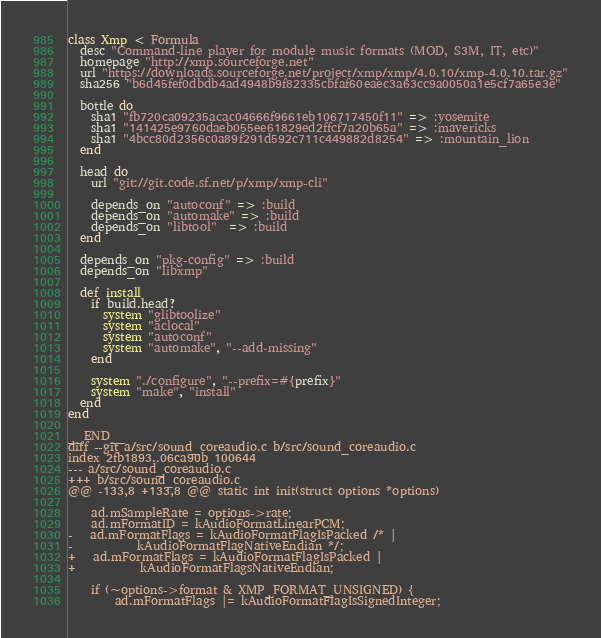Convert code to text. <code><loc_0><loc_0><loc_500><loc_500><_Ruby_>class Xmp < Formula
  desc "Command-line player for module music formats (MOD, S3M, IT, etc)"
  homepage "http://xmp.sourceforge.net"
  url "https://downloads.sourceforge.net/project/xmp/xmp/4.0.10/xmp-4.0.10.tar.gz"
  sha256 "b6d45fef0dbdb4ad4948b9f82335cbfaf60eaec3a63cc9a0050a1e5cf7a65e3e"

  bottle do
    sha1 "fb720ca09235acac04666f9661eb106717450f11" => :yosemite
    sha1 "141425e9760daeb055ee61829ed2ffcf7a20b65a" => :mavericks
    sha1 "4bcc80d2356c0a89f291d592c711c449882d8254" => :mountain_lion
  end

  head do
    url "git://git.code.sf.net/p/xmp/xmp-cli"

    depends_on "autoconf" => :build
    depends_on "automake" => :build
    depends_on "libtool"  => :build
  end

  depends_on "pkg-config" => :build
  depends_on "libxmp"

  def install
    if build.head?
      system "glibtoolize"
      system "aclocal"
      system "autoconf"
      system "automake", "--add-missing"
    end

    system "./configure", "--prefix=#{prefix}"
    system "make", "install"
  end
end

__END__
diff --git a/src/sound_coreaudio.c b/src/sound_coreaudio.c
index 2fb1893..06ca90b 100644
--- a/src/sound_coreaudio.c
+++ b/src/sound_coreaudio.c
@@ -133,8 +133,8 @@ static int init(struct options *options)
 
 	ad.mSampleRate = options->rate;
 	ad.mFormatID = kAudioFormatLinearPCM;
-	ad.mFormatFlags = kAudioFormatFlagIsPacked /* |
-			kAudioFormatFlagNativeEndian */;
+	ad.mFormatFlags = kAudioFormatFlagIsPacked |
+			kAudioFormatFlagsNativeEndian;
 
 	if (~options->format & XMP_FORMAT_UNSIGNED) {
 		ad.mFormatFlags |= kAudioFormatFlagIsSignedInteger;

</code> 